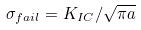<formula> <loc_0><loc_0><loc_500><loc_500>\sigma _ { f a i l } = K _ { I C } / \sqrt { \pi a }</formula> 